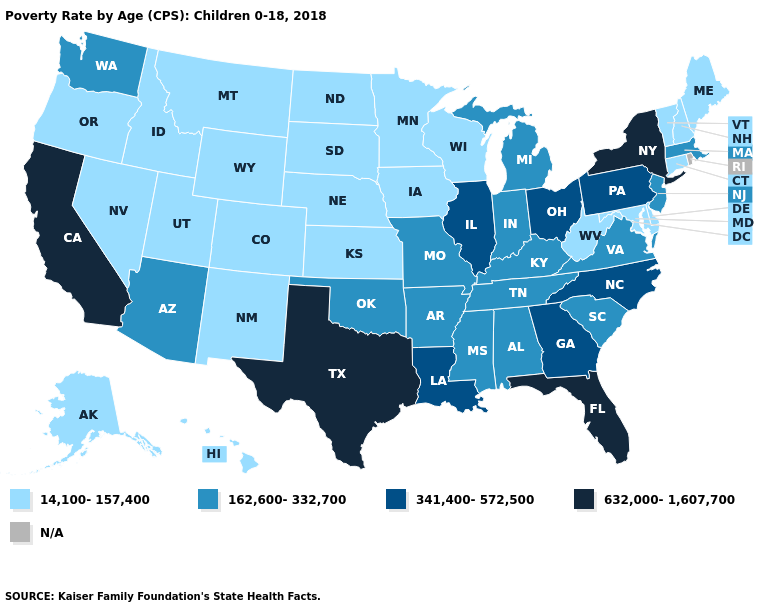What is the lowest value in states that border Iowa?
Keep it brief. 14,100-157,400. What is the lowest value in the USA?
Be succinct. 14,100-157,400. Is the legend a continuous bar?
Write a very short answer. No. What is the value of Rhode Island?
Give a very brief answer. N/A. What is the value of Nevada?
Concise answer only. 14,100-157,400. Name the states that have a value in the range N/A?
Give a very brief answer. Rhode Island. Name the states that have a value in the range N/A?
Be succinct. Rhode Island. What is the value of Iowa?
Keep it brief. 14,100-157,400. Which states hav the highest value in the MidWest?
Keep it brief. Illinois, Ohio. What is the value of Utah?
Short answer required. 14,100-157,400. What is the value of Connecticut?
Answer briefly. 14,100-157,400. Name the states that have a value in the range 14,100-157,400?
Be succinct. Alaska, Colorado, Connecticut, Delaware, Hawaii, Idaho, Iowa, Kansas, Maine, Maryland, Minnesota, Montana, Nebraska, Nevada, New Hampshire, New Mexico, North Dakota, Oregon, South Dakota, Utah, Vermont, West Virginia, Wisconsin, Wyoming. What is the value of Michigan?
Give a very brief answer. 162,600-332,700. 